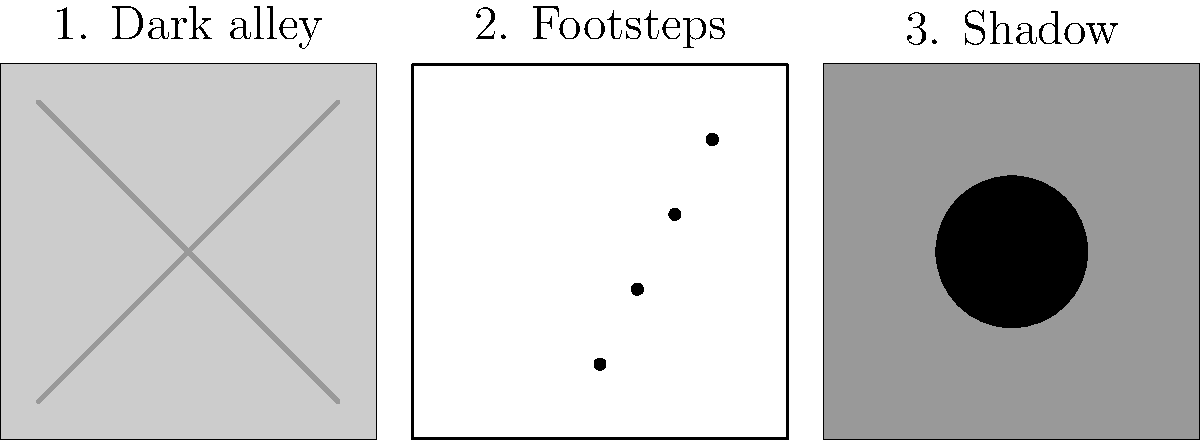As a book editor reviewing a crime writer's manuscript, you come across a scene described using the storyboard above. Which key element of suspense is most prominently depicted in the third panel, and how does it contribute to building tension in the scene? To identify the key element of suspense in the third panel and its contribution to building tension, let's analyze the storyboard step-by-step:

1. Panel 1 shows a dark alley, setting the scene and creating an ominous atmosphere.
2. Panel 2 depicts footsteps, suggesting movement and the approach of a character.
3. Panel 3 displays a prominent shadow, which is the focus of our analysis.

The key element of suspense in the third panel is the use of a shadow. This element contributes to building tension in the scene in several ways:

a) Ambiguity: The shadow doesn't reveal the full identity of the figure, leaving room for the reader's imagination and creating uncertainty.
b) Threat implication: A looming shadow often suggests a menacing presence, heightening the sense of danger.
c) Anticipation: The shadow builds anticipation for what will be revealed next, encouraging the reader to continue.
d) Visual representation of fear: Shadows are commonly associated with the unknown and fear, tapping into primal human emotions.

The use of the shadow as a key element of suspense effectively builds upon the tension established in the previous panels. It progresses from the dark setting to the approaching footsteps, culminating in the ominous shadow that leaves the reader wondering about the nature of the threat and what will happen next.
Answer: The shadow, creating ambiguity and implying threat. 